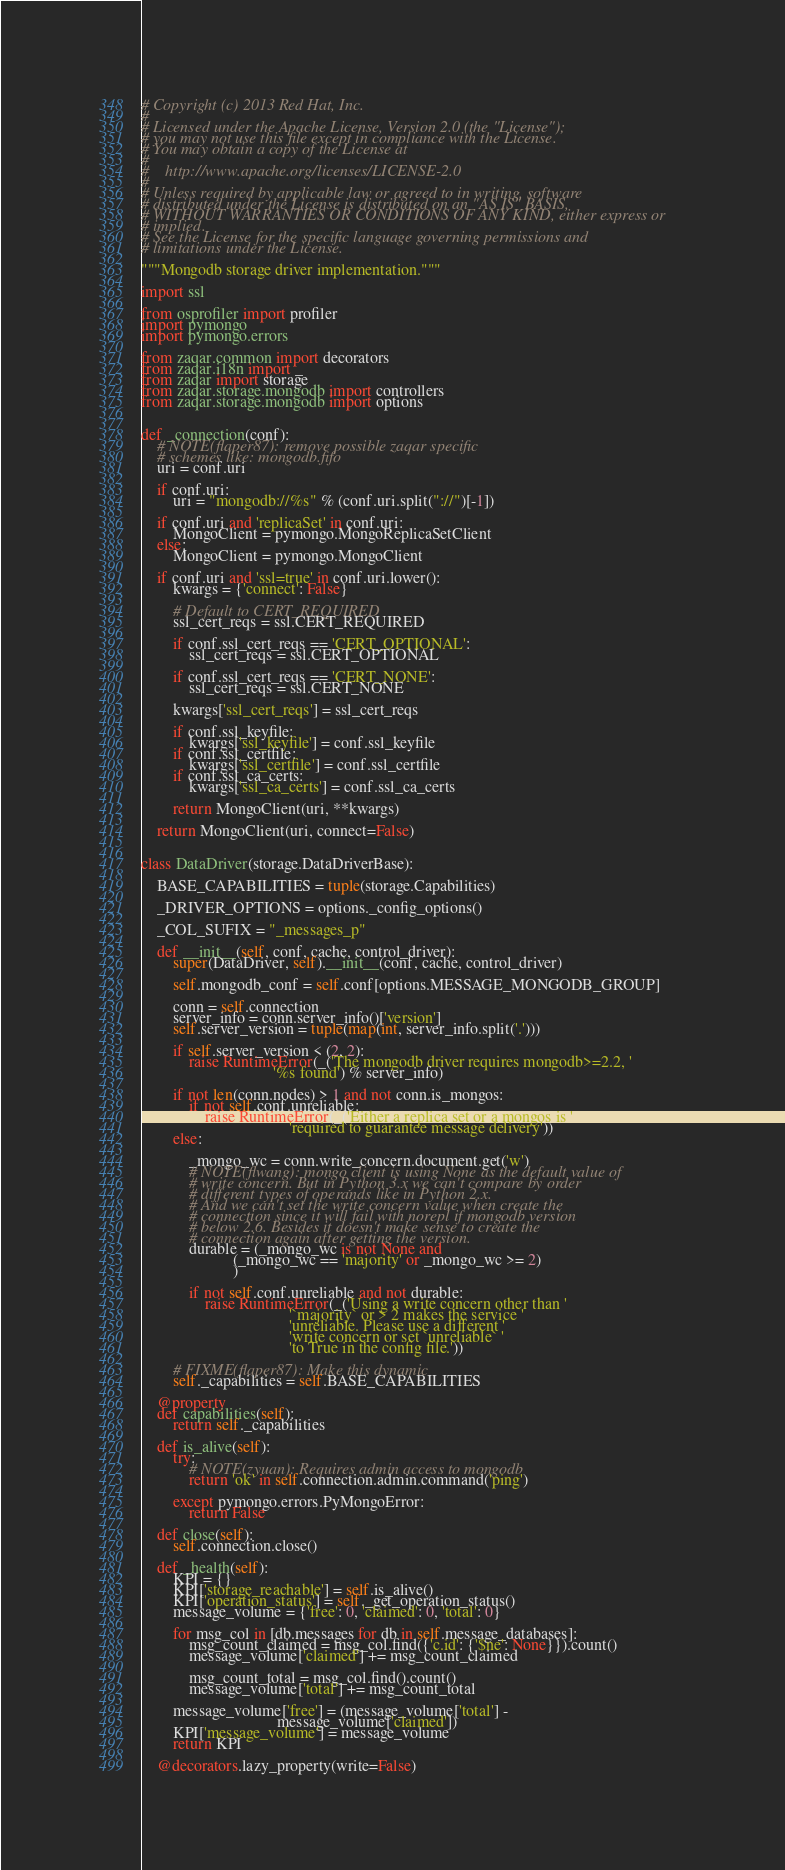<code> <loc_0><loc_0><loc_500><loc_500><_Python_># Copyright (c) 2013 Red Hat, Inc.
#
# Licensed under the Apache License, Version 2.0 (the "License");
# you may not use this file except in compliance with the License.
# You may obtain a copy of the License at
#
#    http://www.apache.org/licenses/LICENSE-2.0
#
# Unless required by applicable law or agreed to in writing, software
# distributed under the License is distributed on an "AS IS" BASIS,
# WITHOUT WARRANTIES OR CONDITIONS OF ANY KIND, either express or
# implied.
# See the License for the specific language governing permissions and
# limitations under the License.

"""Mongodb storage driver implementation."""

import ssl

from osprofiler import profiler
import pymongo
import pymongo.errors

from zaqar.common import decorators
from zaqar.i18n import _
from zaqar import storage
from zaqar.storage.mongodb import controllers
from zaqar.storage.mongodb import options


def _connection(conf):
    # NOTE(flaper87): remove possible zaqar specific
    # schemes like: mongodb.fifo
    uri = conf.uri

    if conf.uri:
        uri = "mongodb://%s" % (conf.uri.split("://")[-1])

    if conf.uri and 'replicaSet' in conf.uri:
        MongoClient = pymongo.MongoReplicaSetClient
    else:
        MongoClient = pymongo.MongoClient

    if conf.uri and 'ssl=true' in conf.uri.lower():
        kwargs = {'connect': False}

        # Default to CERT_REQUIRED
        ssl_cert_reqs = ssl.CERT_REQUIRED

        if conf.ssl_cert_reqs == 'CERT_OPTIONAL':
            ssl_cert_reqs = ssl.CERT_OPTIONAL

        if conf.ssl_cert_reqs == 'CERT_NONE':
            ssl_cert_reqs = ssl.CERT_NONE

        kwargs['ssl_cert_reqs'] = ssl_cert_reqs

        if conf.ssl_keyfile:
            kwargs['ssl_keyfile'] = conf.ssl_keyfile
        if conf.ssl_certfile:
            kwargs['ssl_certfile'] = conf.ssl_certfile
        if conf.ssl_ca_certs:
            kwargs['ssl_ca_certs'] = conf.ssl_ca_certs

        return MongoClient(uri, **kwargs)

    return MongoClient(uri, connect=False)


class DataDriver(storage.DataDriverBase):

    BASE_CAPABILITIES = tuple(storage.Capabilities)

    _DRIVER_OPTIONS = options._config_options()

    _COL_SUFIX = "_messages_p"

    def __init__(self, conf, cache, control_driver):
        super(DataDriver, self).__init__(conf, cache, control_driver)

        self.mongodb_conf = self.conf[options.MESSAGE_MONGODB_GROUP]

        conn = self.connection
        server_info = conn.server_info()['version']
        self.server_version = tuple(map(int, server_info.split('.')))

        if self.server_version < (2, 2):
            raise RuntimeError(_('The mongodb driver requires mongodb>=2.2, '
                                 '%s found') % server_info)

        if not len(conn.nodes) > 1 and not conn.is_mongos:
            if not self.conf.unreliable:
                raise RuntimeError(_('Either a replica set or a mongos is '
                                     'required to guarantee message delivery'))
        else:

            _mongo_wc = conn.write_concern.document.get('w')
            # NOTE(flwang): mongo client is using None as the default value of
            # write concern. But in Python 3.x we can't compare by order
            # different types of operands like in Python 2.x.
            # And we can't set the write concern value when create the
            # connection since it will fail with norepl if mongodb version
            # below 2.6. Besides it doesn't make sense to create the
            # connection again after getting the version.
            durable = (_mongo_wc is not None and
                       (_mongo_wc == 'majority' or _mongo_wc >= 2)
                       )

            if not self.conf.unreliable and not durable:
                raise RuntimeError(_('Using a write concern other than '
                                     '`majority` or > 2 makes the service '
                                     'unreliable. Please use a different '
                                     'write concern or set `unreliable` '
                                     'to True in the config file.'))

        # FIXME(flaper87): Make this dynamic
        self._capabilities = self.BASE_CAPABILITIES

    @property
    def capabilities(self):
        return self._capabilities

    def is_alive(self):
        try:
            # NOTE(zyuan): Requires admin access to mongodb
            return 'ok' in self.connection.admin.command('ping')

        except pymongo.errors.PyMongoError:
            return False

    def close(self):
        self.connection.close()

    def _health(self):
        KPI = {}
        KPI['storage_reachable'] = self.is_alive()
        KPI['operation_status'] = self._get_operation_status()
        message_volume = {'free': 0, 'claimed': 0, 'total': 0}

        for msg_col in [db.messages for db in self.message_databases]:
            msg_count_claimed = msg_col.find({'c.id': {'$ne': None}}).count()
            message_volume['claimed'] += msg_count_claimed

            msg_count_total = msg_col.find().count()
            message_volume['total'] += msg_count_total

        message_volume['free'] = (message_volume['total'] -
                                  message_volume['claimed'])
        KPI['message_volume'] = message_volume
        return KPI

    @decorators.lazy_property(write=False)</code> 